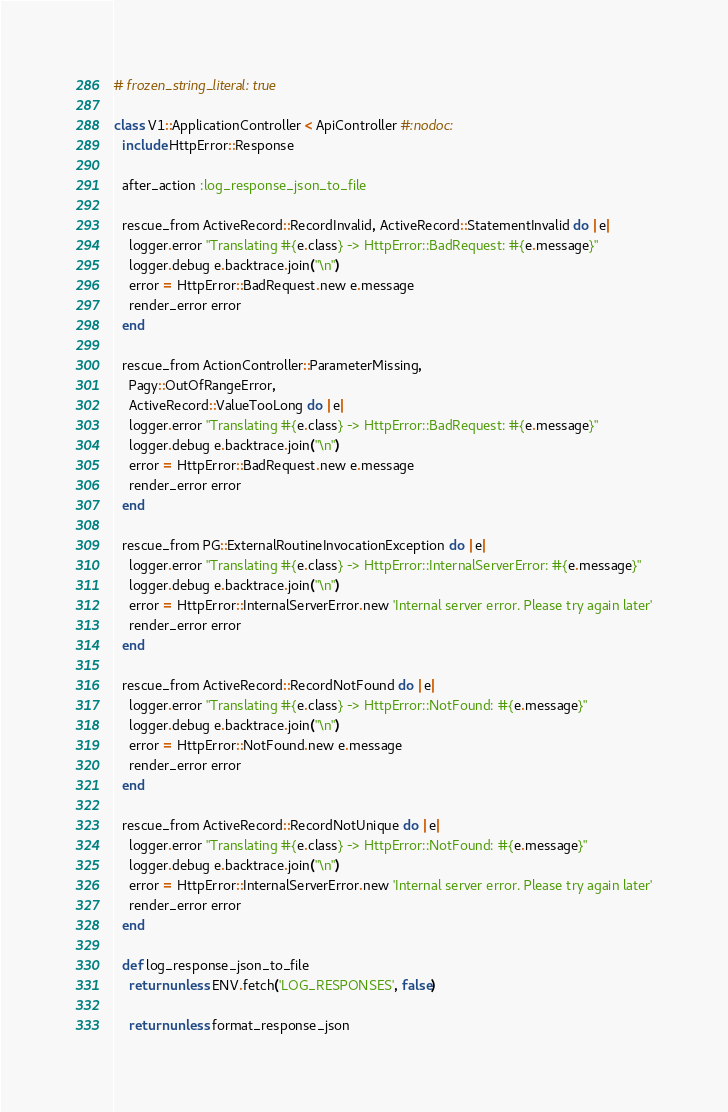<code> <loc_0><loc_0><loc_500><loc_500><_Ruby_># frozen_string_literal: true

class V1::ApplicationController < ApiController #:nodoc:
  include HttpError::Response

  after_action :log_response_json_to_file

  rescue_from ActiveRecord::RecordInvalid, ActiveRecord::StatementInvalid do |e|
    logger.error "Translating #{e.class} -> HttpError::BadRequest: #{e.message}"
    logger.debug e.backtrace.join("\n")
    error = HttpError::BadRequest.new e.message
    render_error error
  end

  rescue_from ActionController::ParameterMissing,
    Pagy::OutOfRangeError,
    ActiveRecord::ValueTooLong do |e|
    logger.error "Translating #{e.class} -> HttpError::BadRequest: #{e.message}"
    logger.debug e.backtrace.join("\n")
    error = HttpError::BadRequest.new e.message
    render_error error
  end

  rescue_from PG::ExternalRoutineInvocationException do |e|
    logger.error "Translating #{e.class} -> HttpError::InternalServerError: #{e.message}"
    logger.debug e.backtrace.join("\n")
    error = HttpError::InternalServerError.new 'Internal server error. Please try again later'
    render_error error
  end

  rescue_from ActiveRecord::RecordNotFound do |e|
    logger.error "Translating #{e.class} -> HttpError::NotFound: #{e.message}"
    logger.debug e.backtrace.join("\n")
    error = HttpError::NotFound.new e.message
    render_error error
  end

  rescue_from ActiveRecord::RecordNotUnique do |e|
    logger.error "Translating #{e.class} -> HttpError::NotFound: #{e.message}"
    logger.debug e.backtrace.join("\n")
    error = HttpError::InternalServerError.new 'Internal server error. Please try again later'
    render_error error
  end

  def log_response_json_to_file
    return unless ENV.fetch('LOG_RESPONSES', false)

    return unless format_response_json
</code> 